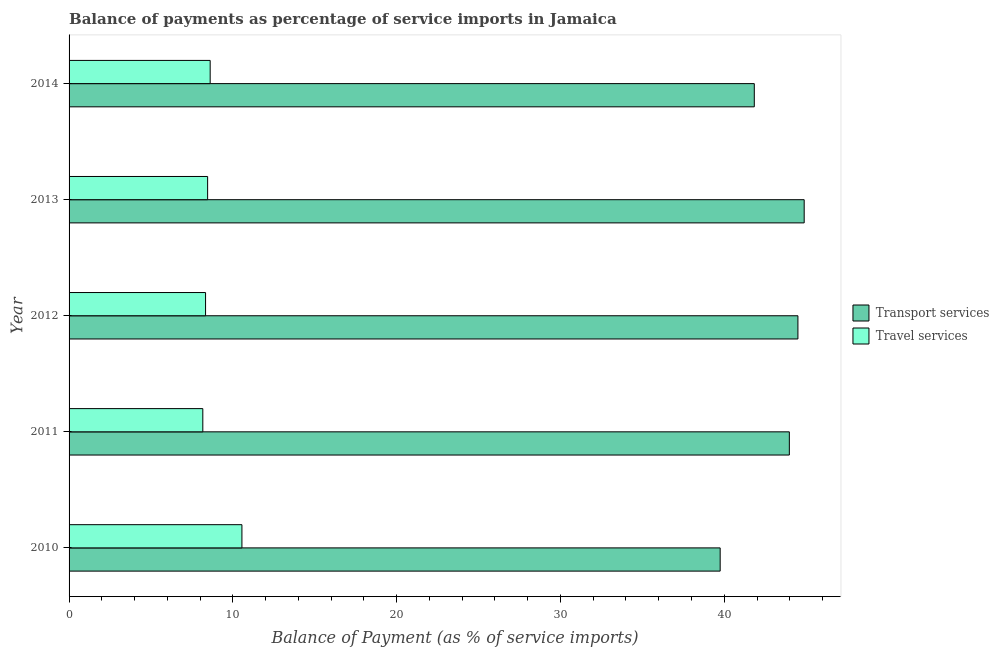Are the number of bars per tick equal to the number of legend labels?
Give a very brief answer. Yes. How many bars are there on the 1st tick from the top?
Provide a succinct answer. 2. What is the balance of payments of travel services in 2012?
Your answer should be compact. 8.33. Across all years, what is the maximum balance of payments of travel services?
Provide a succinct answer. 10.55. Across all years, what is the minimum balance of payments of transport services?
Your response must be concise. 39.75. In which year was the balance of payments of transport services maximum?
Provide a succinct answer. 2013. In which year was the balance of payments of travel services minimum?
Your answer should be compact. 2011. What is the total balance of payments of transport services in the graph?
Offer a terse response. 214.94. What is the difference between the balance of payments of transport services in 2012 and that in 2014?
Offer a very short reply. 2.66. What is the difference between the balance of payments of transport services in 2014 and the balance of payments of travel services in 2013?
Give a very brief answer. 33.38. What is the average balance of payments of transport services per year?
Offer a very short reply. 42.99. In the year 2011, what is the difference between the balance of payments of travel services and balance of payments of transport services?
Provide a succinct answer. -35.81. In how many years, is the balance of payments of transport services greater than 32 %?
Make the answer very short. 5. What is the ratio of the balance of payments of travel services in 2010 to that in 2014?
Offer a terse response. 1.23. Is the balance of payments of travel services in 2011 less than that in 2013?
Offer a very short reply. Yes. What is the difference between the highest and the second highest balance of payments of travel services?
Provide a short and direct response. 1.94. What is the difference between the highest and the lowest balance of payments of transport services?
Ensure brevity in your answer.  5.13. In how many years, is the balance of payments of travel services greater than the average balance of payments of travel services taken over all years?
Offer a terse response. 1. Is the sum of the balance of payments of travel services in 2011 and 2013 greater than the maximum balance of payments of transport services across all years?
Your answer should be compact. No. What does the 2nd bar from the top in 2014 represents?
Provide a succinct answer. Transport services. What does the 2nd bar from the bottom in 2011 represents?
Offer a very short reply. Travel services. How many bars are there?
Offer a very short reply. 10. Are all the bars in the graph horizontal?
Keep it short and to the point. Yes. What is the difference between two consecutive major ticks on the X-axis?
Provide a succinct answer. 10. Where does the legend appear in the graph?
Give a very brief answer. Center right. How many legend labels are there?
Offer a terse response. 2. How are the legend labels stacked?
Offer a terse response. Vertical. What is the title of the graph?
Ensure brevity in your answer.  Balance of payments as percentage of service imports in Jamaica. What is the label or title of the X-axis?
Keep it short and to the point. Balance of Payment (as % of service imports). What is the label or title of the Y-axis?
Your answer should be very brief. Year. What is the Balance of Payment (as % of service imports) in Transport services in 2010?
Offer a terse response. 39.75. What is the Balance of Payment (as % of service imports) of Travel services in 2010?
Provide a succinct answer. 10.55. What is the Balance of Payment (as % of service imports) of Transport services in 2011?
Provide a short and direct response. 43.97. What is the Balance of Payment (as % of service imports) in Travel services in 2011?
Provide a succinct answer. 8.17. What is the Balance of Payment (as % of service imports) in Transport services in 2012?
Ensure brevity in your answer.  44.5. What is the Balance of Payment (as % of service imports) in Travel services in 2012?
Make the answer very short. 8.33. What is the Balance of Payment (as % of service imports) in Transport services in 2013?
Your answer should be compact. 44.88. What is the Balance of Payment (as % of service imports) of Travel services in 2013?
Make the answer very short. 8.46. What is the Balance of Payment (as % of service imports) in Transport services in 2014?
Your response must be concise. 41.83. What is the Balance of Payment (as % of service imports) of Travel services in 2014?
Your answer should be compact. 8.61. Across all years, what is the maximum Balance of Payment (as % of service imports) of Transport services?
Provide a short and direct response. 44.88. Across all years, what is the maximum Balance of Payment (as % of service imports) of Travel services?
Your answer should be compact. 10.55. Across all years, what is the minimum Balance of Payment (as % of service imports) of Transport services?
Give a very brief answer. 39.75. Across all years, what is the minimum Balance of Payment (as % of service imports) in Travel services?
Offer a terse response. 8.17. What is the total Balance of Payment (as % of service imports) of Transport services in the graph?
Make the answer very short. 214.94. What is the total Balance of Payment (as % of service imports) of Travel services in the graph?
Your answer should be very brief. 44.12. What is the difference between the Balance of Payment (as % of service imports) in Transport services in 2010 and that in 2011?
Make the answer very short. -4.22. What is the difference between the Balance of Payment (as % of service imports) in Travel services in 2010 and that in 2011?
Offer a terse response. 2.39. What is the difference between the Balance of Payment (as % of service imports) of Transport services in 2010 and that in 2012?
Your answer should be compact. -4.75. What is the difference between the Balance of Payment (as % of service imports) in Travel services in 2010 and that in 2012?
Provide a short and direct response. 2.22. What is the difference between the Balance of Payment (as % of service imports) of Transport services in 2010 and that in 2013?
Offer a terse response. -5.13. What is the difference between the Balance of Payment (as % of service imports) of Travel services in 2010 and that in 2013?
Your answer should be very brief. 2.09. What is the difference between the Balance of Payment (as % of service imports) in Transport services in 2010 and that in 2014?
Your response must be concise. -2.08. What is the difference between the Balance of Payment (as % of service imports) in Travel services in 2010 and that in 2014?
Provide a succinct answer. 1.94. What is the difference between the Balance of Payment (as % of service imports) of Transport services in 2011 and that in 2012?
Make the answer very short. -0.52. What is the difference between the Balance of Payment (as % of service imports) in Travel services in 2011 and that in 2012?
Your response must be concise. -0.17. What is the difference between the Balance of Payment (as % of service imports) of Transport services in 2011 and that in 2013?
Offer a very short reply. -0.91. What is the difference between the Balance of Payment (as % of service imports) of Travel services in 2011 and that in 2013?
Ensure brevity in your answer.  -0.29. What is the difference between the Balance of Payment (as % of service imports) of Transport services in 2011 and that in 2014?
Ensure brevity in your answer.  2.14. What is the difference between the Balance of Payment (as % of service imports) of Travel services in 2011 and that in 2014?
Your answer should be compact. -0.45. What is the difference between the Balance of Payment (as % of service imports) in Transport services in 2012 and that in 2013?
Make the answer very short. -0.38. What is the difference between the Balance of Payment (as % of service imports) in Travel services in 2012 and that in 2013?
Provide a short and direct response. -0.13. What is the difference between the Balance of Payment (as % of service imports) in Transport services in 2012 and that in 2014?
Provide a succinct answer. 2.66. What is the difference between the Balance of Payment (as % of service imports) in Travel services in 2012 and that in 2014?
Your response must be concise. -0.28. What is the difference between the Balance of Payment (as % of service imports) in Transport services in 2013 and that in 2014?
Your response must be concise. 3.05. What is the difference between the Balance of Payment (as % of service imports) in Travel services in 2013 and that in 2014?
Keep it short and to the point. -0.16. What is the difference between the Balance of Payment (as % of service imports) of Transport services in 2010 and the Balance of Payment (as % of service imports) of Travel services in 2011?
Make the answer very short. 31.59. What is the difference between the Balance of Payment (as % of service imports) in Transport services in 2010 and the Balance of Payment (as % of service imports) in Travel services in 2012?
Offer a very short reply. 31.42. What is the difference between the Balance of Payment (as % of service imports) in Transport services in 2010 and the Balance of Payment (as % of service imports) in Travel services in 2013?
Offer a terse response. 31.29. What is the difference between the Balance of Payment (as % of service imports) in Transport services in 2010 and the Balance of Payment (as % of service imports) in Travel services in 2014?
Your answer should be compact. 31.14. What is the difference between the Balance of Payment (as % of service imports) in Transport services in 2011 and the Balance of Payment (as % of service imports) in Travel services in 2012?
Give a very brief answer. 35.64. What is the difference between the Balance of Payment (as % of service imports) in Transport services in 2011 and the Balance of Payment (as % of service imports) in Travel services in 2013?
Make the answer very short. 35.51. What is the difference between the Balance of Payment (as % of service imports) of Transport services in 2011 and the Balance of Payment (as % of service imports) of Travel services in 2014?
Keep it short and to the point. 35.36. What is the difference between the Balance of Payment (as % of service imports) of Transport services in 2012 and the Balance of Payment (as % of service imports) of Travel services in 2013?
Offer a terse response. 36.04. What is the difference between the Balance of Payment (as % of service imports) in Transport services in 2012 and the Balance of Payment (as % of service imports) in Travel services in 2014?
Give a very brief answer. 35.88. What is the difference between the Balance of Payment (as % of service imports) in Transport services in 2013 and the Balance of Payment (as % of service imports) in Travel services in 2014?
Ensure brevity in your answer.  36.27. What is the average Balance of Payment (as % of service imports) of Transport services per year?
Keep it short and to the point. 42.99. What is the average Balance of Payment (as % of service imports) in Travel services per year?
Provide a succinct answer. 8.82. In the year 2010, what is the difference between the Balance of Payment (as % of service imports) in Transport services and Balance of Payment (as % of service imports) in Travel services?
Provide a succinct answer. 29.2. In the year 2011, what is the difference between the Balance of Payment (as % of service imports) of Transport services and Balance of Payment (as % of service imports) of Travel services?
Your response must be concise. 35.81. In the year 2012, what is the difference between the Balance of Payment (as % of service imports) of Transport services and Balance of Payment (as % of service imports) of Travel services?
Ensure brevity in your answer.  36.16. In the year 2013, what is the difference between the Balance of Payment (as % of service imports) of Transport services and Balance of Payment (as % of service imports) of Travel services?
Keep it short and to the point. 36.42. In the year 2014, what is the difference between the Balance of Payment (as % of service imports) in Transport services and Balance of Payment (as % of service imports) in Travel services?
Give a very brief answer. 33.22. What is the ratio of the Balance of Payment (as % of service imports) in Transport services in 2010 to that in 2011?
Keep it short and to the point. 0.9. What is the ratio of the Balance of Payment (as % of service imports) of Travel services in 2010 to that in 2011?
Offer a terse response. 1.29. What is the ratio of the Balance of Payment (as % of service imports) of Transport services in 2010 to that in 2012?
Offer a very short reply. 0.89. What is the ratio of the Balance of Payment (as % of service imports) in Travel services in 2010 to that in 2012?
Provide a short and direct response. 1.27. What is the ratio of the Balance of Payment (as % of service imports) in Transport services in 2010 to that in 2013?
Ensure brevity in your answer.  0.89. What is the ratio of the Balance of Payment (as % of service imports) of Travel services in 2010 to that in 2013?
Your answer should be very brief. 1.25. What is the ratio of the Balance of Payment (as % of service imports) of Transport services in 2010 to that in 2014?
Give a very brief answer. 0.95. What is the ratio of the Balance of Payment (as % of service imports) of Travel services in 2010 to that in 2014?
Ensure brevity in your answer.  1.23. What is the ratio of the Balance of Payment (as % of service imports) of Travel services in 2011 to that in 2012?
Provide a succinct answer. 0.98. What is the ratio of the Balance of Payment (as % of service imports) in Transport services in 2011 to that in 2013?
Offer a terse response. 0.98. What is the ratio of the Balance of Payment (as % of service imports) in Travel services in 2011 to that in 2013?
Your answer should be very brief. 0.97. What is the ratio of the Balance of Payment (as % of service imports) of Transport services in 2011 to that in 2014?
Your response must be concise. 1.05. What is the ratio of the Balance of Payment (as % of service imports) in Travel services in 2011 to that in 2014?
Ensure brevity in your answer.  0.95. What is the ratio of the Balance of Payment (as % of service imports) of Travel services in 2012 to that in 2013?
Give a very brief answer. 0.99. What is the ratio of the Balance of Payment (as % of service imports) in Transport services in 2012 to that in 2014?
Provide a succinct answer. 1.06. What is the ratio of the Balance of Payment (as % of service imports) in Travel services in 2012 to that in 2014?
Offer a terse response. 0.97. What is the ratio of the Balance of Payment (as % of service imports) of Transport services in 2013 to that in 2014?
Provide a succinct answer. 1.07. What is the difference between the highest and the second highest Balance of Payment (as % of service imports) of Transport services?
Your response must be concise. 0.38. What is the difference between the highest and the second highest Balance of Payment (as % of service imports) in Travel services?
Provide a short and direct response. 1.94. What is the difference between the highest and the lowest Balance of Payment (as % of service imports) of Transport services?
Give a very brief answer. 5.13. What is the difference between the highest and the lowest Balance of Payment (as % of service imports) of Travel services?
Your response must be concise. 2.39. 